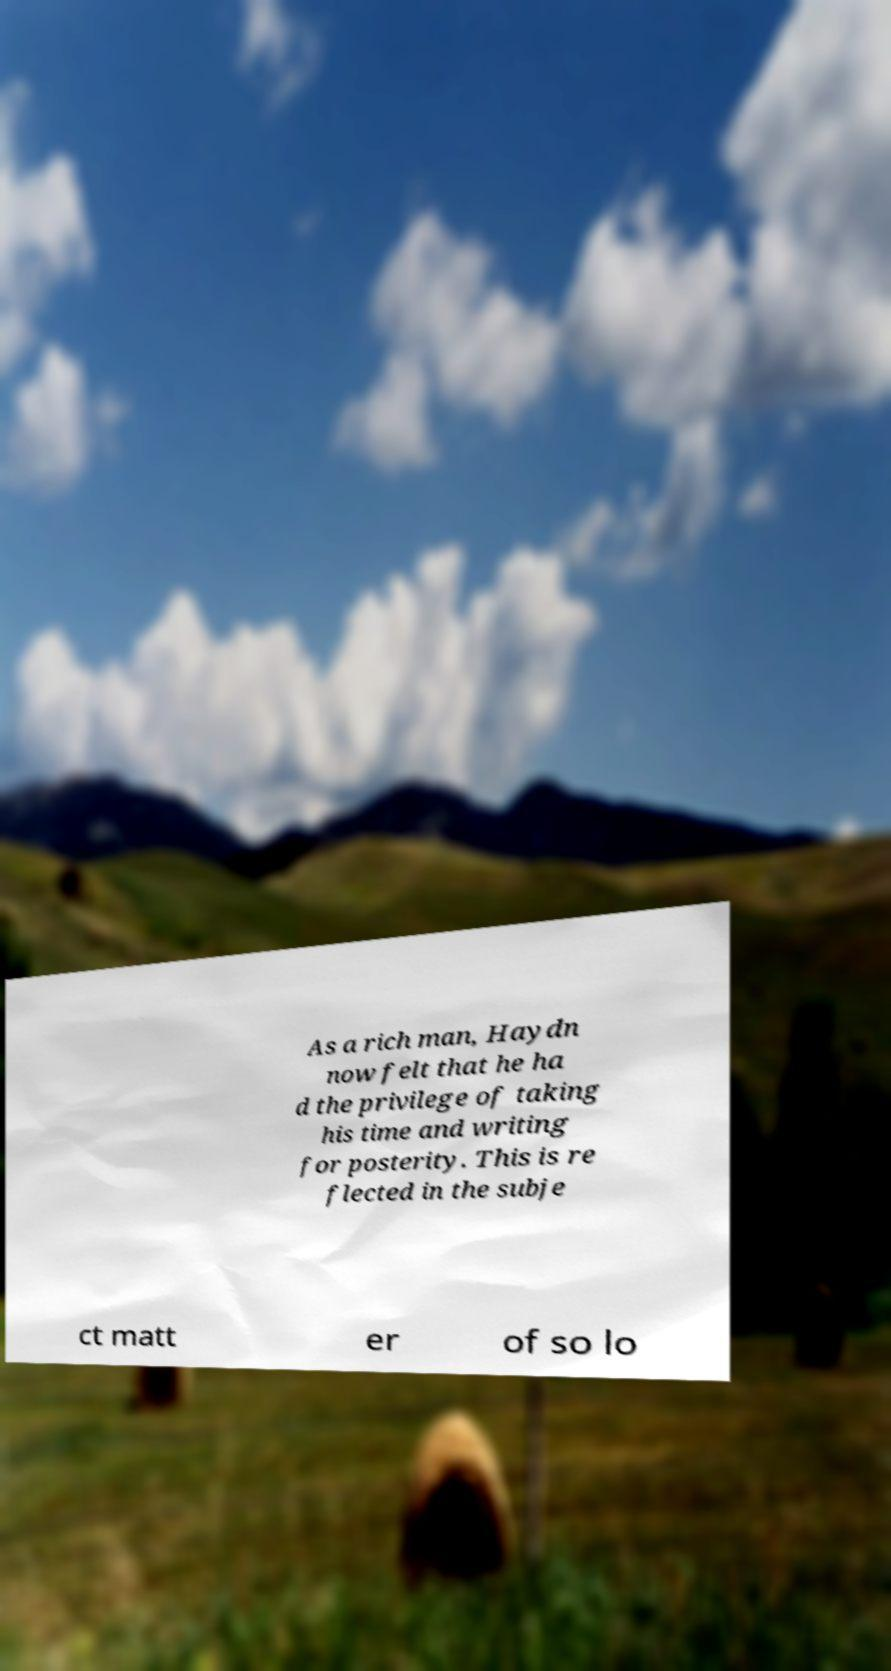Can you read and provide the text displayed in the image?This photo seems to have some interesting text. Can you extract and type it out for me? As a rich man, Haydn now felt that he ha d the privilege of taking his time and writing for posterity. This is re flected in the subje ct matt er of so lo 